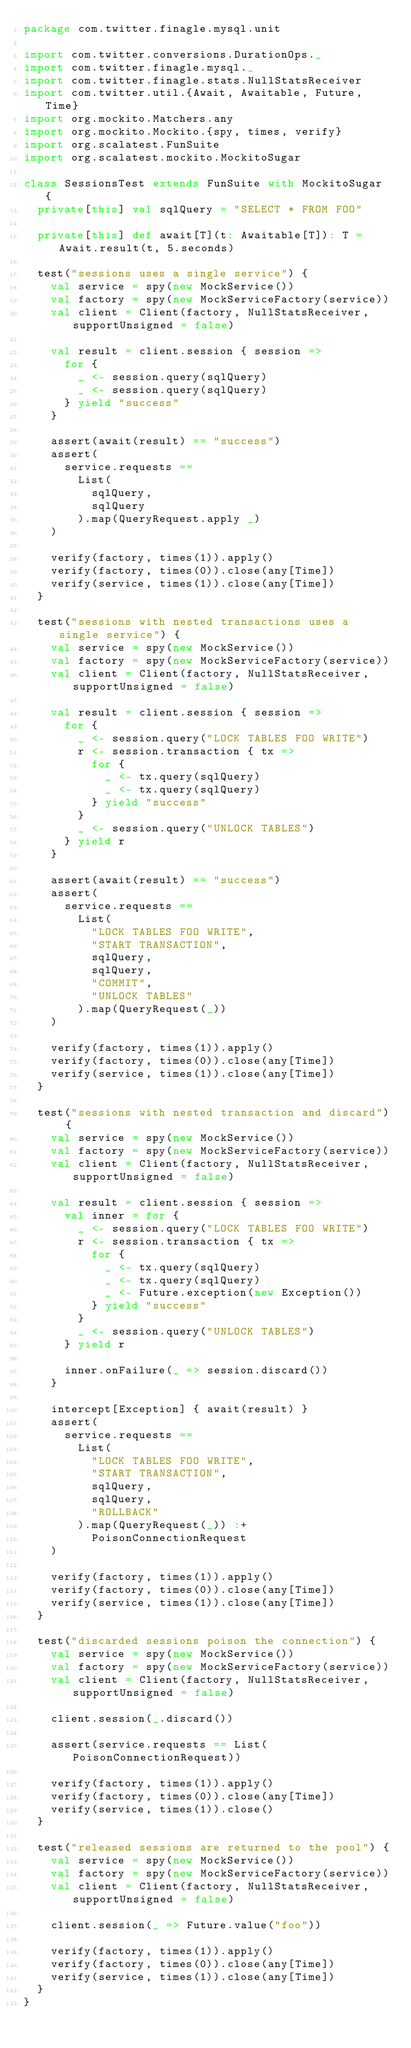<code> <loc_0><loc_0><loc_500><loc_500><_Scala_>package com.twitter.finagle.mysql.unit

import com.twitter.conversions.DurationOps._
import com.twitter.finagle.mysql._
import com.twitter.finagle.stats.NullStatsReceiver
import com.twitter.util.{Await, Awaitable, Future, Time}
import org.mockito.Matchers.any
import org.mockito.Mockito.{spy, times, verify}
import org.scalatest.FunSuite
import org.scalatest.mockito.MockitoSugar

class SessionsTest extends FunSuite with MockitoSugar {
  private[this] val sqlQuery = "SELECT * FROM FOO"

  private[this] def await[T](t: Awaitable[T]): T = Await.result(t, 5.seconds)

  test("sessions uses a single service") {
    val service = spy(new MockService())
    val factory = spy(new MockServiceFactory(service))
    val client = Client(factory, NullStatsReceiver, supportUnsigned = false)

    val result = client.session { session =>
      for {
        _ <- session.query(sqlQuery)
        _ <- session.query(sqlQuery)
      } yield "success"
    }

    assert(await(result) == "success")
    assert(
      service.requests ==
        List(
          sqlQuery,
          sqlQuery
        ).map(QueryRequest.apply _)
    )

    verify(factory, times(1)).apply()
    verify(factory, times(0)).close(any[Time])
    verify(service, times(1)).close(any[Time])
  }

  test("sessions with nested transactions uses a single service") {
    val service = spy(new MockService())
    val factory = spy(new MockServiceFactory(service))
    val client = Client(factory, NullStatsReceiver, supportUnsigned = false)

    val result = client.session { session =>
      for {
        _ <- session.query("LOCK TABLES FOO WRITE")
        r <- session.transaction { tx =>
          for {
            _ <- tx.query(sqlQuery)
            _ <- tx.query(sqlQuery)
          } yield "success"
        }
        _ <- session.query("UNLOCK TABLES")
      } yield r
    }

    assert(await(result) == "success")
    assert(
      service.requests ==
        List(
          "LOCK TABLES FOO WRITE",
          "START TRANSACTION",
          sqlQuery,
          sqlQuery,
          "COMMIT",
          "UNLOCK TABLES"
        ).map(QueryRequest(_))
    )

    verify(factory, times(1)).apply()
    verify(factory, times(0)).close(any[Time])
    verify(service, times(1)).close(any[Time])
  }

  test("sessions with nested transaction and discard") {
    val service = spy(new MockService())
    val factory = spy(new MockServiceFactory(service))
    val client = Client(factory, NullStatsReceiver, supportUnsigned = false)

    val result = client.session { session =>
      val inner = for {
        _ <- session.query("LOCK TABLES FOO WRITE")
        r <- session.transaction { tx =>
          for {
            _ <- tx.query(sqlQuery)
            _ <- tx.query(sqlQuery)
            _ <- Future.exception(new Exception())
          } yield "success"
        }
        _ <- session.query("UNLOCK TABLES")
      } yield r

      inner.onFailure(_ => session.discard())
    }

    intercept[Exception] { await(result) }
    assert(
      service.requests ==
        List(
          "LOCK TABLES FOO WRITE",
          "START TRANSACTION",
          sqlQuery,
          sqlQuery,
          "ROLLBACK"
        ).map(QueryRequest(_)) :+
          PoisonConnectionRequest
    )

    verify(factory, times(1)).apply()
    verify(factory, times(0)).close(any[Time])
    verify(service, times(1)).close(any[Time])
  }

  test("discarded sessions poison the connection") {
    val service = spy(new MockService())
    val factory = spy(new MockServiceFactory(service))
    val client = Client(factory, NullStatsReceiver, supportUnsigned = false)

    client.session(_.discard())

    assert(service.requests == List(PoisonConnectionRequest))

    verify(factory, times(1)).apply()
    verify(factory, times(0)).close(any[Time])
    verify(service, times(1)).close()
  }

  test("released sessions are returned to the pool") {
    val service = spy(new MockService())
    val factory = spy(new MockServiceFactory(service))
    val client = Client(factory, NullStatsReceiver, supportUnsigned = false)

    client.session(_ => Future.value("foo"))

    verify(factory, times(1)).apply()
    verify(factory, times(0)).close(any[Time])
    verify(service, times(1)).close(any[Time])
  }
}
</code> 